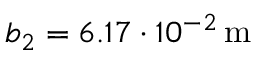<formula> <loc_0><loc_0><loc_500><loc_500>b _ { 2 } = 6 . 1 7 \cdot 1 0 ^ { - 2 } \, m</formula> 